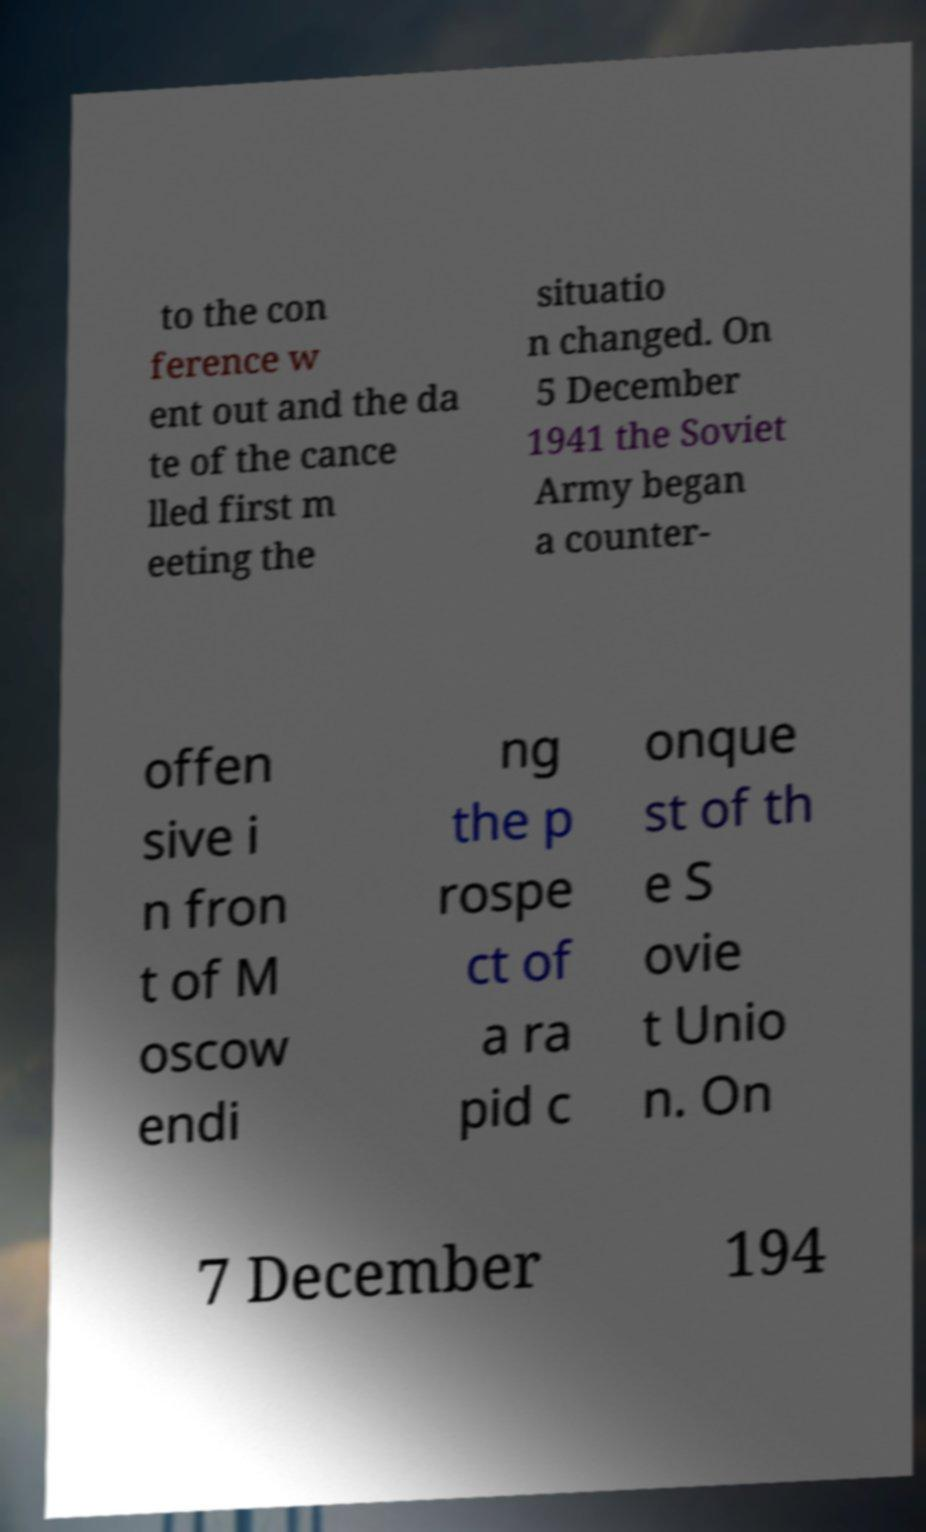Please read and relay the text visible in this image. What does it say? to the con ference w ent out and the da te of the cance lled first m eeting the situatio n changed. On 5 December 1941 the Soviet Army began a counter- offen sive i n fron t of M oscow endi ng the p rospe ct of a ra pid c onque st of th e S ovie t Unio n. On 7 December 194 